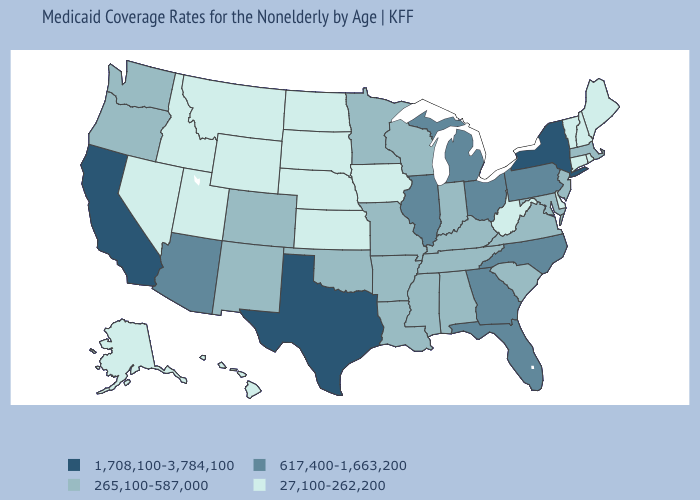Does Tennessee have a higher value than Arizona?
Answer briefly. No. Name the states that have a value in the range 1,708,100-3,784,100?
Write a very short answer. California, New York, Texas. Is the legend a continuous bar?
Quick response, please. No. What is the value of Louisiana?
Keep it brief. 265,100-587,000. What is the value of Ohio?
Be succinct. 617,400-1,663,200. Does the map have missing data?
Be succinct. No. What is the value of Missouri?
Answer briefly. 265,100-587,000. Does Idaho have the lowest value in the West?
Give a very brief answer. Yes. Does the first symbol in the legend represent the smallest category?
Answer briefly. No. What is the value of New Jersey?
Short answer required. 265,100-587,000. Name the states that have a value in the range 617,400-1,663,200?
Concise answer only. Arizona, Florida, Georgia, Illinois, Michigan, North Carolina, Ohio, Pennsylvania. What is the lowest value in the South?
Be succinct. 27,100-262,200. Among the states that border Pennsylvania , does New Jersey have the lowest value?
Concise answer only. No. What is the value of Louisiana?
Be succinct. 265,100-587,000. 